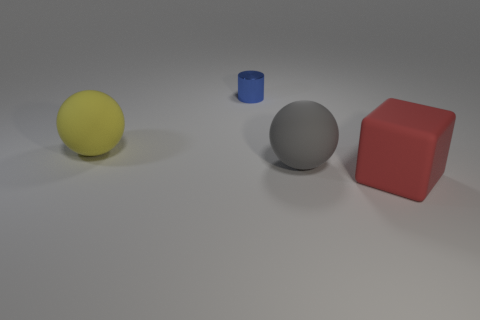There is a big object that is behind the large block and to the right of the metal object; what is its material?
Your response must be concise. Rubber. Is there any other thing that has the same shape as the big yellow matte object?
Give a very brief answer. Yes. What is the color of the cube that is made of the same material as the yellow ball?
Offer a terse response. Red. What number of objects are either large cyan matte things or small things?
Offer a very short reply. 1. There is a gray object; is it the same size as the rubber object that is to the left of the shiny cylinder?
Your answer should be compact. Yes. What is the color of the big rubber object to the left of the big rubber sphere that is to the right of the sphere behind the big gray matte object?
Provide a short and direct response. Yellow. The tiny metallic cylinder is what color?
Your answer should be compact. Blue. Is the number of matte balls that are to the right of the blue metal cylinder greater than the number of big red matte cubes in front of the big red matte block?
Give a very brief answer. Yes. Do the yellow matte thing and the gray object that is right of the small cylinder have the same shape?
Your response must be concise. Yes. There is a matte object that is to the left of the gray matte object; is it the same size as the sphere in front of the large yellow rubber object?
Your answer should be very brief. Yes. 